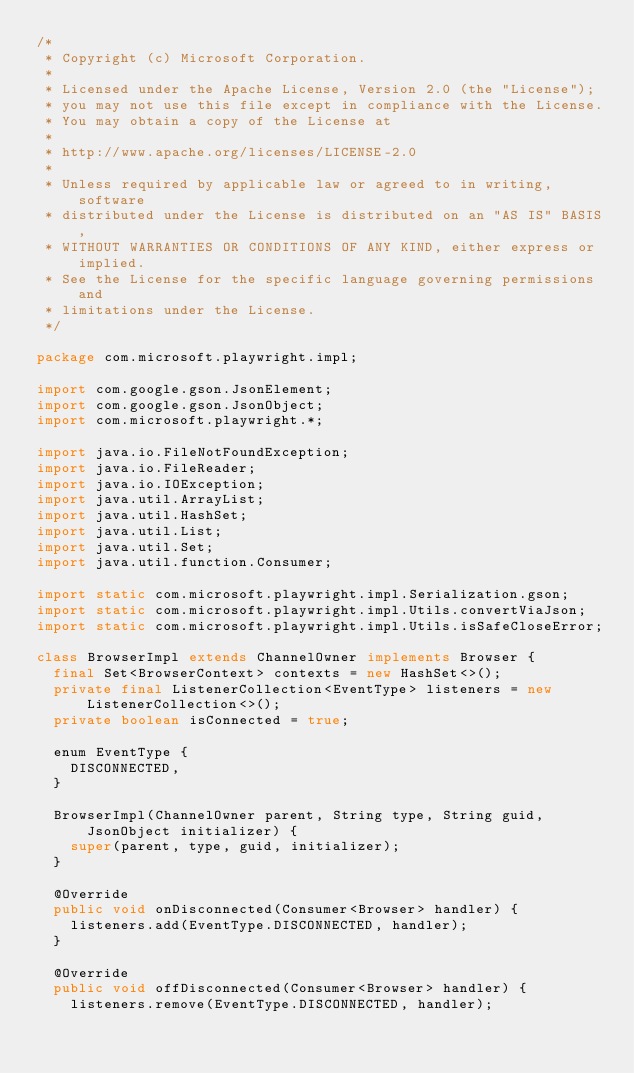Convert code to text. <code><loc_0><loc_0><loc_500><loc_500><_Java_>/*
 * Copyright (c) Microsoft Corporation.
 *
 * Licensed under the Apache License, Version 2.0 (the "License");
 * you may not use this file except in compliance with the License.
 * You may obtain a copy of the License at
 *
 * http://www.apache.org/licenses/LICENSE-2.0
 *
 * Unless required by applicable law or agreed to in writing, software
 * distributed under the License is distributed on an "AS IS" BASIS,
 * WITHOUT WARRANTIES OR CONDITIONS OF ANY KIND, either express or implied.
 * See the License for the specific language governing permissions and
 * limitations under the License.
 */

package com.microsoft.playwright.impl;

import com.google.gson.JsonElement;
import com.google.gson.JsonObject;
import com.microsoft.playwright.*;

import java.io.FileNotFoundException;
import java.io.FileReader;
import java.io.IOException;
import java.util.ArrayList;
import java.util.HashSet;
import java.util.List;
import java.util.Set;
import java.util.function.Consumer;

import static com.microsoft.playwright.impl.Serialization.gson;
import static com.microsoft.playwright.impl.Utils.convertViaJson;
import static com.microsoft.playwright.impl.Utils.isSafeCloseError;

class BrowserImpl extends ChannelOwner implements Browser {
  final Set<BrowserContext> contexts = new HashSet<>();
  private final ListenerCollection<EventType> listeners = new ListenerCollection<>();
  private boolean isConnected = true;

  enum EventType {
    DISCONNECTED,
  }

  BrowserImpl(ChannelOwner parent, String type, String guid, JsonObject initializer) {
    super(parent, type, guid, initializer);
  }

  @Override
  public void onDisconnected(Consumer<Browser> handler) {
    listeners.add(EventType.DISCONNECTED, handler);
  }

  @Override
  public void offDisconnected(Consumer<Browser> handler) {
    listeners.remove(EventType.DISCONNECTED, handler);</code> 